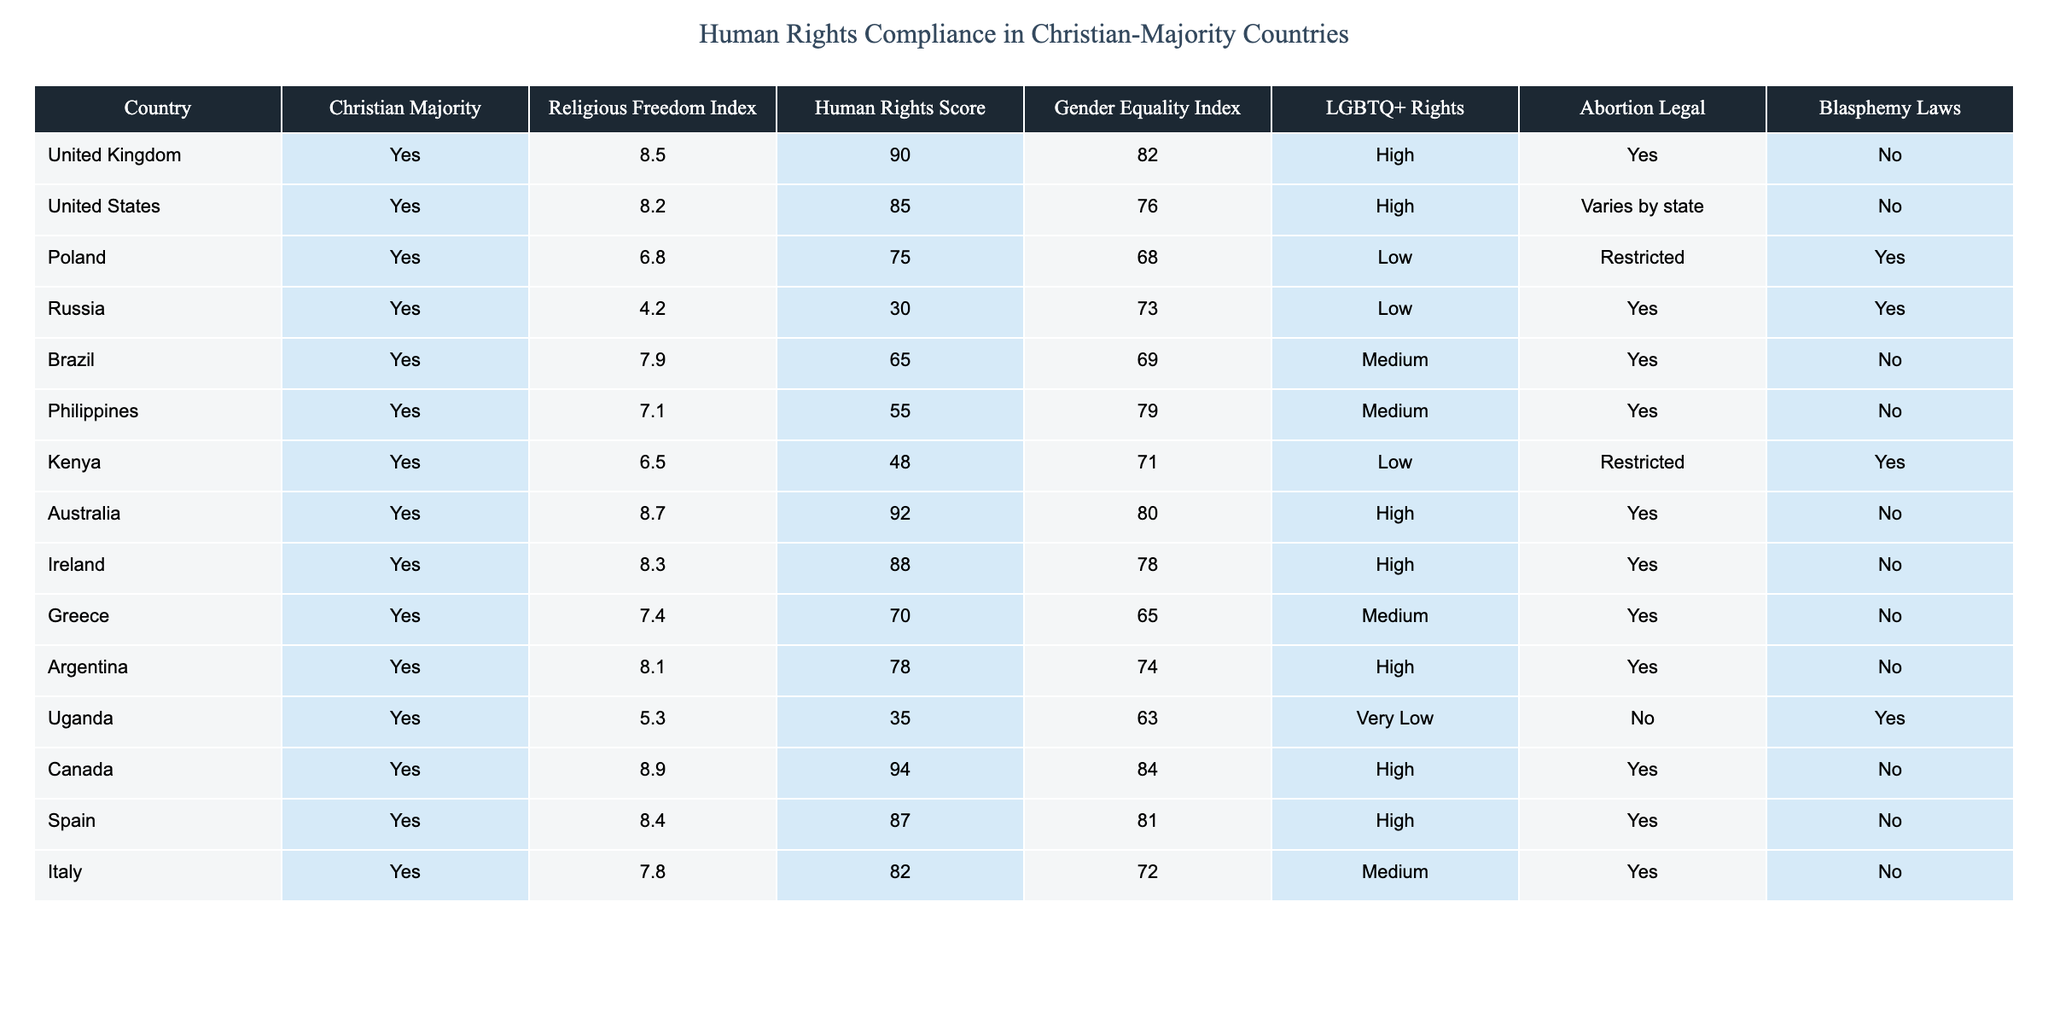What is the Religious Freedom Index of Canada? The table lists Canada with a Religious Freedom Index of 8.9, which can be found in the respective row for that country.
Answer: 8.9 Which country has the lowest Human Rights Score among the listed Christian-majority countries? By examining the Human Rights Score column, Russia has the lowest score of 30, as indicated in the table.
Answer: 30 Is abortion legal in Poland? The table shows that in Poland, abortion is marked as "Restricted," which indicates that it is not fully legal.
Answer: No What is the average Gender Equality Index among the countries listed? Adding the Gender Equality Index values: (82 + 76 + 68 + 73 + 69 + 79 + 71 + 80 + 78 + 65 + 74 + 63 + 84 + 81 + 72) = 1235. There are 15 countries, so the average is 1235/15 = 82.33.
Answer: 82.33 Which country with a Christian majority has the highest LGBTQ+ rights rating? Checking the LGBTQ+ Rights column, countries like the United Kingdom, Canada, Australia, and others have a "High" rating. However, the United Kingdom is the first one listed with this rating.
Answer: United Kingdom Do any of the listed countries have both blasphemy laws and a low Human Rights Score? By reviewing the rows, Poland, Russia, and Uganda have blasphemy laws marked as "Yes" and Human Rights Scores of 75, 30, and 35, respectively. Thus, there are multiple countries that fit this criterion.
Answer: Yes What is the difference between the Human Rights Score of Kenya and Brazil? The Human Rights Score for Kenya is 48, and for Brazil, it is 65. The difference is 65 - 48 = 17.
Answer: 17 How many countries in the table have a Gender Equality Index rated as "High"? Referring to the Gender Equality Index column, the countries rated as "High" are the United Kingdom, Australia, Canada, and Argentina, totaling to 4 countries.
Answer: 4 What conclusion can be drawn about the relationship between Religious Freedom Index and Human Rights Score in Australia compared to Russia? Australia has a Religious Freedom Index of 8.7 and a Human Rights Score of 92, while Russia has a low Religious Freedom Index of 4.2 and a Human Rights Score of 30, indicating that higher religious freedom correlates with better human rights in these cases.
Answer: Higher religious freedom relates to better human rights 